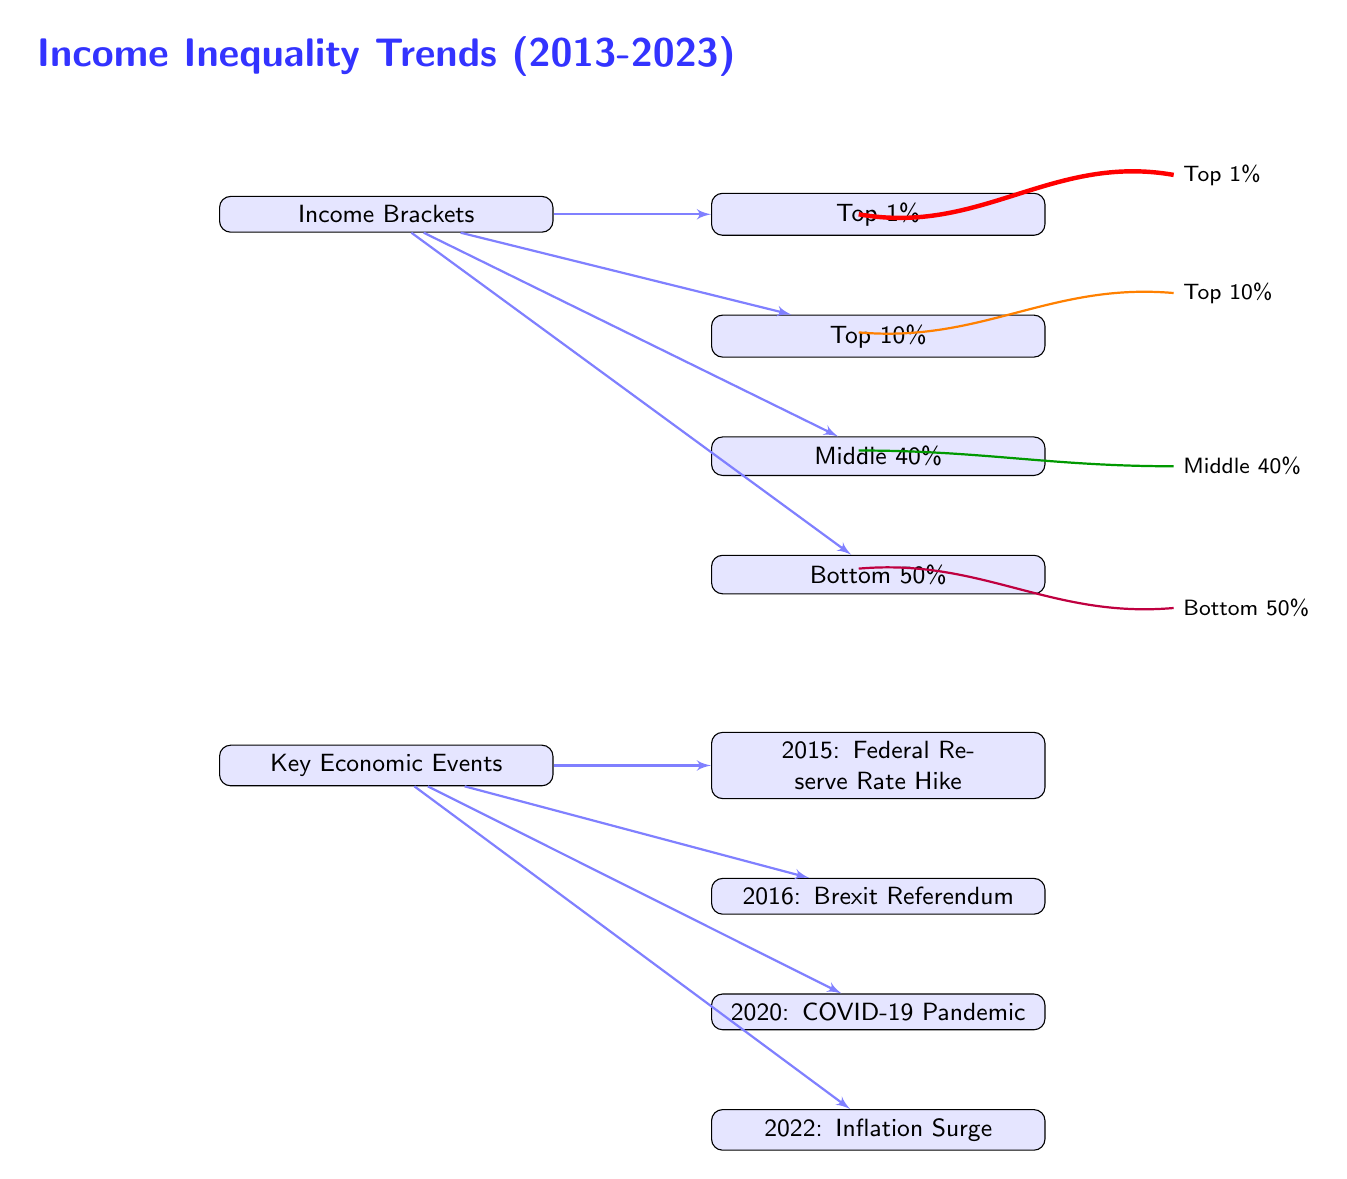What are the four income brackets depicted? The diagram lists four income brackets as the top 1%, top 10%, middle 40%, and bottom 50%. These labels are clearly marked in the income bracket section of the diagram.
Answer: top 1%, top 10%, middle 40%, bottom 50% Which economic event occurred in 2020? The diagram indicates that the COVID-19 Pandemic occurred in 2020, as this label is situated clearly in the key economic events section.
Answer: COVID-19 Pandemic How many income brackets are shown in the diagram? There are four distinct income brackets indicated in the diagram, each separated visually and labeled correspondingly within the income brackets section.
Answer: 4 What color represents the Top 10% income trend? The line representing the Top 10% income trend is colored orange, as indicated in the legend on the right side of the diagram.
Answer: orange Which two economic events are aligned with the income brackets? The events of 2015 and 2020 are aligned with the changes in income brackets; the Federal Reserve Rate Hike from 2015 is positioned with the change in upper incomes, while the COVID-19 Pandemic from 2020 shows a significant impact downward.
Answer: 2015 and 2020 How has the trend for the Bottom 50% changed since 2013? The downward trend line for the Bottom 50% indicates a decrease in income over the observed period, highlighting a concerning trend of worsening inequality for this bracket.
Answer: decreased What is the trend line style used for the Middle 40%? The Middle 40% income trend is represented by a thick green line, as denoted in the legend.
Answer: thick green In what year did Brexit occur, according to the diagram? The Brexit Referendum occurred in 2016, which is clearly marked in the key economic events section of the diagram.
Answer: 2016 What does the title of the diagram signify? The title "Income Inequality Trends (2013-2023)" signifies that the content of the diagram illustrates various trends related to income inequality over this specific timeframe.
Answer: Income Inequality Trends (2013-2023) 